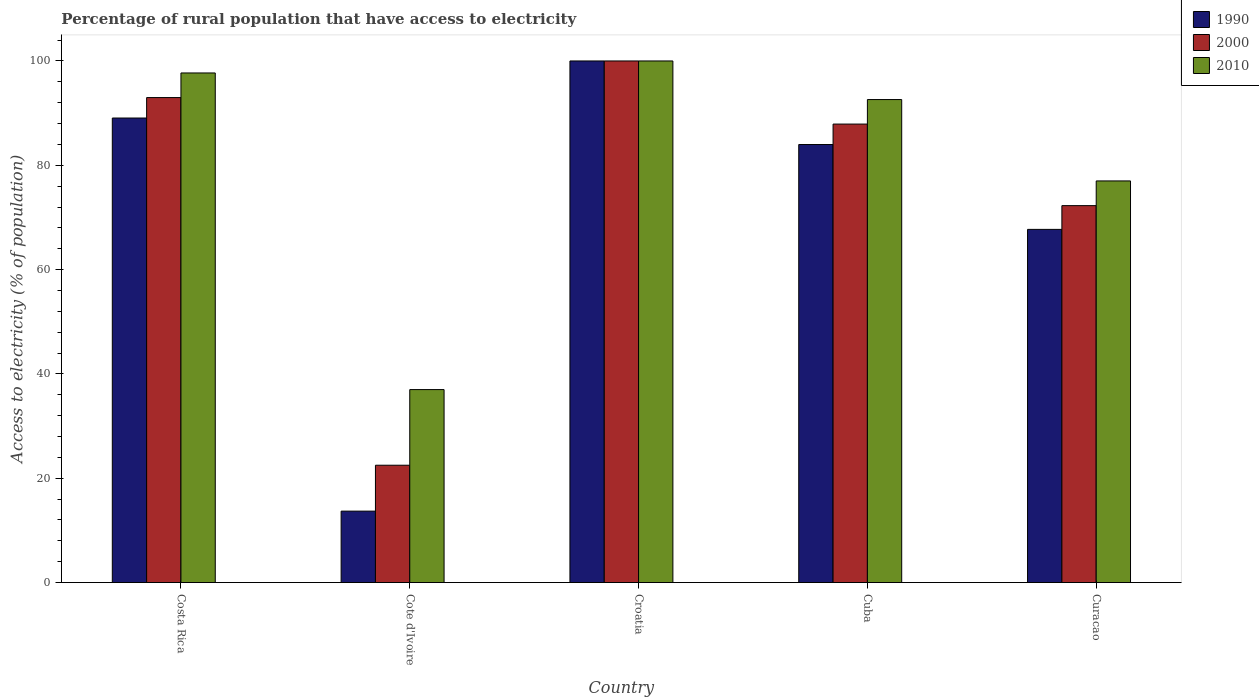How many groups of bars are there?
Your answer should be compact. 5. Are the number of bars on each tick of the X-axis equal?
Offer a terse response. Yes. How many bars are there on the 3rd tick from the left?
Offer a very short reply. 3. How many bars are there on the 4th tick from the right?
Make the answer very short. 3. What is the label of the 3rd group of bars from the left?
Offer a very short reply. Croatia. In how many cases, is the number of bars for a given country not equal to the number of legend labels?
Your answer should be compact. 0. What is the percentage of rural population that have access to electricity in 2010 in Cuba?
Offer a very short reply. 92.6. Across all countries, what is the minimum percentage of rural population that have access to electricity in 1990?
Ensure brevity in your answer.  13.7. In which country was the percentage of rural population that have access to electricity in 2010 maximum?
Your answer should be compact. Croatia. In which country was the percentage of rural population that have access to electricity in 2010 minimum?
Offer a terse response. Cote d'Ivoire. What is the total percentage of rural population that have access to electricity in 2010 in the graph?
Make the answer very short. 404.3. What is the difference between the percentage of rural population that have access to electricity in 2010 in Costa Rica and that in Cote d'Ivoire?
Offer a terse response. 60.7. What is the difference between the percentage of rural population that have access to electricity in 2010 in Croatia and the percentage of rural population that have access to electricity in 1990 in Cuba?
Offer a very short reply. 16.02. What is the average percentage of rural population that have access to electricity in 1990 per country?
Make the answer very short. 70.89. In how many countries, is the percentage of rural population that have access to electricity in 1990 greater than 20 %?
Make the answer very short. 4. What is the ratio of the percentage of rural population that have access to electricity in 2010 in Cote d'Ivoire to that in Curacao?
Your answer should be compact. 0.48. What is the difference between the highest and the second highest percentage of rural population that have access to electricity in 2000?
Offer a terse response. 12.1. What is the difference between the highest and the lowest percentage of rural population that have access to electricity in 1990?
Your response must be concise. 86.3. Is the sum of the percentage of rural population that have access to electricity in 2010 in Croatia and Curacao greater than the maximum percentage of rural population that have access to electricity in 1990 across all countries?
Your response must be concise. Yes. What does the 3rd bar from the left in Cuba represents?
Give a very brief answer. 2010. Is it the case that in every country, the sum of the percentage of rural population that have access to electricity in 2000 and percentage of rural population that have access to electricity in 2010 is greater than the percentage of rural population that have access to electricity in 1990?
Give a very brief answer. Yes. Are all the bars in the graph horizontal?
Your answer should be compact. No. How many countries are there in the graph?
Make the answer very short. 5. Does the graph contain any zero values?
Give a very brief answer. No. Where does the legend appear in the graph?
Ensure brevity in your answer.  Top right. How many legend labels are there?
Ensure brevity in your answer.  3. How are the legend labels stacked?
Provide a succinct answer. Vertical. What is the title of the graph?
Make the answer very short. Percentage of rural population that have access to electricity. What is the label or title of the Y-axis?
Your answer should be very brief. Access to electricity (% of population). What is the Access to electricity (% of population) of 1990 in Costa Rica?
Offer a terse response. 89.06. What is the Access to electricity (% of population) in 2000 in Costa Rica?
Make the answer very short. 92.98. What is the Access to electricity (% of population) of 2010 in Costa Rica?
Your response must be concise. 97.7. What is the Access to electricity (% of population) of 1990 in Croatia?
Offer a terse response. 100. What is the Access to electricity (% of population) in 2000 in Croatia?
Make the answer very short. 100. What is the Access to electricity (% of population) in 2010 in Croatia?
Provide a succinct answer. 100. What is the Access to electricity (% of population) of 1990 in Cuba?
Make the answer very short. 83.98. What is the Access to electricity (% of population) in 2000 in Cuba?
Keep it short and to the point. 87.9. What is the Access to electricity (% of population) of 2010 in Cuba?
Offer a very short reply. 92.6. What is the Access to electricity (% of population) in 1990 in Curacao?
Make the answer very short. 67.71. What is the Access to electricity (% of population) of 2000 in Curacao?
Your answer should be very brief. 72.27. What is the Access to electricity (% of population) in 2010 in Curacao?
Keep it short and to the point. 77. Across all countries, what is the maximum Access to electricity (% of population) of 2010?
Your answer should be compact. 100. Across all countries, what is the minimum Access to electricity (% of population) in 2000?
Keep it short and to the point. 22.5. Across all countries, what is the minimum Access to electricity (% of population) in 2010?
Your answer should be very brief. 37. What is the total Access to electricity (% of population) of 1990 in the graph?
Make the answer very short. 354.45. What is the total Access to electricity (% of population) in 2000 in the graph?
Make the answer very short. 375.65. What is the total Access to electricity (% of population) of 2010 in the graph?
Provide a succinct answer. 404.3. What is the difference between the Access to electricity (% of population) in 1990 in Costa Rica and that in Cote d'Ivoire?
Provide a short and direct response. 75.36. What is the difference between the Access to electricity (% of population) of 2000 in Costa Rica and that in Cote d'Ivoire?
Ensure brevity in your answer.  70.48. What is the difference between the Access to electricity (% of population) of 2010 in Costa Rica and that in Cote d'Ivoire?
Keep it short and to the point. 60.7. What is the difference between the Access to electricity (% of population) in 1990 in Costa Rica and that in Croatia?
Offer a terse response. -10.94. What is the difference between the Access to electricity (% of population) in 2000 in Costa Rica and that in Croatia?
Provide a succinct answer. -7.02. What is the difference between the Access to electricity (% of population) in 1990 in Costa Rica and that in Cuba?
Offer a very short reply. 5.08. What is the difference between the Access to electricity (% of population) in 2000 in Costa Rica and that in Cuba?
Provide a short and direct response. 5.08. What is the difference between the Access to electricity (% of population) in 1990 in Costa Rica and that in Curacao?
Your response must be concise. 21.35. What is the difference between the Access to electricity (% of population) of 2000 in Costa Rica and that in Curacao?
Your answer should be very brief. 20.72. What is the difference between the Access to electricity (% of population) of 2010 in Costa Rica and that in Curacao?
Offer a terse response. 20.7. What is the difference between the Access to electricity (% of population) of 1990 in Cote d'Ivoire and that in Croatia?
Your answer should be compact. -86.3. What is the difference between the Access to electricity (% of population) of 2000 in Cote d'Ivoire and that in Croatia?
Offer a terse response. -77.5. What is the difference between the Access to electricity (% of population) of 2010 in Cote d'Ivoire and that in Croatia?
Your answer should be compact. -63. What is the difference between the Access to electricity (% of population) in 1990 in Cote d'Ivoire and that in Cuba?
Ensure brevity in your answer.  -70.28. What is the difference between the Access to electricity (% of population) in 2000 in Cote d'Ivoire and that in Cuba?
Your answer should be very brief. -65.4. What is the difference between the Access to electricity (% of population) of 2010 in Cote d'Ivoire and that in Cuba?
Give a very brief answer. -55.6. What is the difference between the Access to electricity (% of population) of 1990 in Cote d'Ivoire and that in Curacao?
Provide a short and direct response. -54.01. What is the difference between the Access to electricity (% of population) of 2000 in Cote d'Ivoire and that in Curacao?
Offer a terse response. -49.77. What is the difference between the Access to electricity (% of population) in 2010 in Cote d'Ivoire and that in Curacao?
Give a very brief answer. -40. What is the difference between the Access to electricity (% of population) of 1990 in Croatia and that in Cuba?
Make the answer very short. 16.02. What is the difference between the Access to electricity (% of population) in 1990 in Croatia and that in Curacao?
Your answer should be compact. 32.29. What is the difference between the Access to electricity (% of population) of 2000 in Croatia and that in Curacao?
Ensure brevity in your answer.  27.73. What is the difference between the Access to electricity (% of population) in 1990 in Cuba and that in Curacao?
Offer a terse response. 16.27. What is the difference between the Access to electricity (% of population) of 2000 in Cuba and that in Curacao?
Make the answer very short. 15.63. What is the difference between the Access to electricity (% of population) of 2010 in Cuba and that in Curacao?
Your response must be concise. 15.6. What is the difference between the Access to electricity (% of population) in 1990 in Costa Rica and the Access to electricity (% of population) in 2000 in Cote d'Ivoire?
Make the answer very short. 66.56. What is the difference between the Access to electricity (% of population) in 1990 in Costa Rica and the Access to electricity (% of population) in 2010 in Cote d'Ivoire?
Offer a very short reply. 52.06. What is the difference between the Access to electricity (% of population) in 2000 in Costa Rica and the Access to electricity (% of population) in 2010 in Cote d'Ivoire?
Make the answer very short. 55.98. What is the difference between the Access to electricity (% of population) in 1990 in Costa Rica and the Access to electricity (% of population) in 2000 in Croatia?
Your answer should be compact. -10.94. What is the difference between the Access to electricity (% of population) of 1990 in Costa Rica and the Access to electricity (% of population) of 2010 in Croatia?
Give a very brief answer. -10.94. What is the difference between the Access to electricity (% of population) in 2000 in Costa Rica and the Access to electricity (% of population) in 2010 in Croatia?
Offer a terse response. -7.02. What is the difference between the Access to electricity (% of population) of 1990 in Costa Rica and the Access to electricity (% of population) of 2000 in Cuba?
Your answer should be compact. 1.16. What is the difference between the Access to electricity (% of population) in 1990 in Costa Rica and the Access to electricity (% of population) in 2010 in Cuba?
Ensure brevity in your answer.  -3.54. What is the difference between the Access to electricity (% of population) in 2000 in Costa Rica and the Access to electricity (% of population) in 2010 in Cuba?
Provide a short and direct response. 0.38. What is the difference between the Access to electricity (% of population) in 1990 in Costa Rica and the Access to electricity (% of population) in 2000 in Curacao?
Give a very brief answer. 16.8. What is the difference between the Access to electricity (% of population) of 1990 in Costa Rica and the Access to electricity (% of population) of 2010 in Curacao?
Ensure brevity in your answer.  12.06. What is the difference between the Access to electricity (% of population) of 2000 in Costa Rica and the Access to electricity (% of population) of 2010 in Curacao?
Keep it short and to the point. 15.98. What is the difference between the Access to electricity (% of population) of 1990 in Cote d'Ivoire and the Access to electricity (% of population) of 2000 in Croatia?
Your answer should be compact. -86.3. What is the difference between the Access to electricity (% of population) in 1990 in Cote d'Ivoire and the Access to electricity (% of population) in 2010 in Croatia?
Your response must be concise. -86.3. What is the difference between the Access to electricity (% of population) in 2000 in Cote d'Ivoire and the Access to electricity (% of population) in 2010 in Croatia?
Offer a terse response. -77.5. What is the difference between the Access to electricity (% of population) of 1990 in Cote d'Ivoire and the Access to electricity (% of population) of 2000 in Cuba?
Make the answer very short. -74.2. What is the difference between the Access to electricity (% of population) of 1990 in Cote d'Ivoire and the Access to electricity (% of population) of 2010 in Cuba?
Provide a succinct answer. -78.9. What is the difference between the Access to electricity (% of population) in 2000 in Cote d'Ivoire and the Access to electricity (% of population) in 2010 in Cuba?
Give a very brief answer. -70.1. What is the difference between the Access to electricity (% of population) of 1990 in Cote d'Ivoire and the Access to electricity (% of population) of 2000 in Curacao?
Give a very brief answer. -58.56. What is the difference between the Access to electricity (% of population) in 1990 in Cote d'Ivoire and the Access to electricity (% of population) in 2010 in Curacao?
Offer a terse response. -63.3. What is the difference between the Access to electricity (% of population) in 2000 in Cote d'Ivoire and the Access to electricity (% of population) in 2010 in Curacao?
Provide a succinct answer. -54.5. What is the difference between the Access to electricity (% of population) in 1990 in Croatia and the Access to electricity (% of population) in 2000 in Cuba?
Give a very brief answer. 12.1. What is the difference between the Access to electricity (% of population) in 1990 in Croatia and the Access to electricity (% of population) in 2000 in Curacao?
Provide a succinct answer. 27.73. What is the difference between the Access to electricity (% of population) of 1990 in Cuba and the Access to electricity (% of population) of 2000 in Curacao?
Provide a succinct answer. 11.71. What is the difference between the Access to electricity (% of population) in 1990 in Cuba and the Access to electricity (% of population) in 2010 in Curacao?
Provide a succinct answer. 6.98. What is the difference between the Access to electricity (% of population) in 2000 in Cuba and the Access to electricity (% of population) in 2010 in Curacao?
Your answer should be very brief. 10.9. What is the average Access to electricity (% of population) in 1990 per country?
Give a very brief answer. 70.89. What is the average Access to electricity (% of population) in 2000 per country?
Make the answer very short. 75.13. What is the average Access to electricity (% of population) of 2010 per country?
Make the answer very short. 80.86. What is the difference between the Access to electricity (% of population) of 1990 and Access to electricity (% of population) of 2000 in Costa Rica?
Your answer should be compact. -3.92. What is the difference between the Access to electricity (% of population) in 1990 and Access to electricity (% of population) in 2010 in Costa Rica?
Offer a very short reply. -8.64. What is the difference between the Access to electricity (% of population) of 2000 and Access to electricity (% of population) of 2010 in Costa Rica?
Make the answer very short. -4.72. What is the difference between the Access to electricity (% of population) in 1990 and Access to electricity (% of population) in 2010 in Cote d'Ivoire?
Keep it short and to the point. -23.3. What is the difference between the Access to electricity (% of population) of 1990 and Access to electricity (% of population) of 2000 in Croatia?
Offer a very short reply. 0. What is the difference between the Access to electricity (% of population) of 2000 and Access to electricity (% of population) of 2010 in Croatia?
Provide a short and direct response. 0. What is the difference between the Access to electricity (% of population) in 1990 and Access to electricity (% of population) in 2000 in Cuba?
Make the answer very short. -3.92. What is the difference between the Access to electricity (% of population) in 1990 and Access to electricity (% of population) in 2010 in Cuba?
Offer a terse response. -8.62. What is the difference between the Access to electricity (% of population) of 1990 and Access to electricity (% of population) of 2000 in Curacao?
Give a very brief answer. -4.55. What is the difference between the Access to electricity (% of population) of 1990 and Access to electricity (% of population) of 2010 in Curacao?
Provide a short and direct response. -9.29. What is the difference between the Access to electricity (% of population) in 2000 and Access to electricity (% of population) in 2010 in Curacao?
Keep it short and to the point. -4.74. What is the ratio of the Access to electricity (% of population) of 1990 in Costa Rica to that in Cote d'Ivoire?
Your answer should be very brief. 6.5. What is the ratio of the Access to electricity (% of population) of 2000 in Costa Rica to that in Cote d'Ivoire?
Offer a terse response. 4.13. What is the ratio of the Access to electricity (% of population) of 2010 in Costa Rica to that in Cote d'Ivoire?
Offer a very short reply. 2.64. What is the ratio of the Access to electricity (% of population) in 1990 in Costa Rica to that in Croatia?
Your answer should be compact. 0.89. What is the ratio of the Access to electricity (% of population) in 2000 in Costa Rica to that in Croatia?
Your response must be concise. 0.93. What is the ratio of the Access to electricity (% of population) in 2010 in Costa Rica to that in Croatia?
Offer a very short reply. 0.98. What is the ratio of the Access to electricity (% of population) in 1990 in Costa Rica to that in Cuba?
Keep it short and to the point. 1.06. What is the ratio of the Access to electricity (% of population) of 2000 in Costa Rica to that in Cuba?
Offer a very short reply. 1.06. What is the ratio of the Access to electricity (% of population) of 2010 in Costa Rica to that in Cuba?
Provide a short and direct response. 1.06. What is the ratio of the Access to electricity (% of population) in 1990 in Costa Rica to that in Curacao?
Make the answer very short. 1.32. What is the ratio of the Access to electricity (% of population) of 2000 in Costa Rica to that in Curacao?
Give a very brief answer. 1.29. What is the ratio of the Access to electricity (% of population) of 2010 in Costa Rica to that in Curacao?
Make the answer very short. 1.27. What is the ratio of the Access to electricity (% of population) of 1990 in Cote d'Ivoire to that in Croatia?
Provide a succinct answer. 0.14. What is the ratio of the Access to electricity (% of population) in 2000 in Cote d'Ivoire to that in Croatia?
Give a very brief answer. 0.23. What is the ratio of the Access to electricity (% of population) in 2010 in Cote d'Ivoire to that in Croatia?
Offer a very short reply. 0.37. What is the ratio of the Access to electricity (% of population) of 1990 in Cote d'Ivoire to that in Cuba?
Provide a succinct answer. 0.16. What is the ratio of the Access to electricity (% of population) in 2000 in Cote d'Ivoire to that in Cuba?
Provide a short and direct response. 0.26. What is the ratio of the Access to electricity (% of population) of 2010 in Cote d'Ivoire to that in Cuba?
Make the answer very short. 0.4. What is the ratio of the Access to electricity (% of population) of 1990 in Cote d'Ivoire to that in Curacao?
Your answer should be very brief. 0.2. What is the ratio of the Access to electricity (% of population) of 2000 in Cote d'Ivoire to that in Curacao?
Provide a succinct answer. 0.31. What is the ratio of the Access to electricity (% of population) of 2010 in Cote d'Ivoire to that in Curacao?
Your response must be concise. 0.48. What is the ratio of the Access to electricity (% of population) in 1990 in Croatia to that in Cuba?
Your answer should be very brief. 1.19. What is the ratio of the Access to electricity (% of population) in 2000 in Croatia to that in Cuba?
Make the answer very short. 1.14. What is the ratio of the Access to electricity (% of population) in 2010 in Croatia to that in Cuba?
Offer a very short reply. 1.08. What is the ratio of the Access to electricity (% of population) in 1990 in Croatia to that in Curacao?
Offer a terse response. 1.48. What is the ratio of the Access to electricity (% of population) of 2000 in Croatia to that in Curacao?
Keep it short and to the point. 1.38. What is the ratio of the Access to electricity (% of population) in 2010 in Croatia to that in Curacao?
Offer a terse response. 1.3. What is the ratio of the Access to electricity (% of population) of 1990 in Cuba to that in Curacao?
Ensure brevity in your answer.  1.24. What is the ratio of the Access to electricity (% of population) of 2000 in Cuba to that in Curacao?
Ensure brevity in your answer.  1.22. What is the ratio of the Access to electricity (% of population) of 2010 in Cuba to that in Curacao?
Offer a terse response. 1.2. What is the difference between the highest and the second highest Access to electricity (% of population) of 1990?
Give a very brief answer. 10.94. What is the difference between the highest and the second highest Access to electricity (% of population) of 2000?
Offer a terse response. 7.02. What is the difference between the highest and the lowest Access to electricity (% of population) in 1990?
Provide a succinct answer. 86.3. What is the difference between the highest and the lowest Access to electricity (% of population) of 2000?
Your response must be concise. 77.5. What is the difference between the highest and the lowest Access to electricity (% of population) of 2010?
Offer a very short reply. 63. 